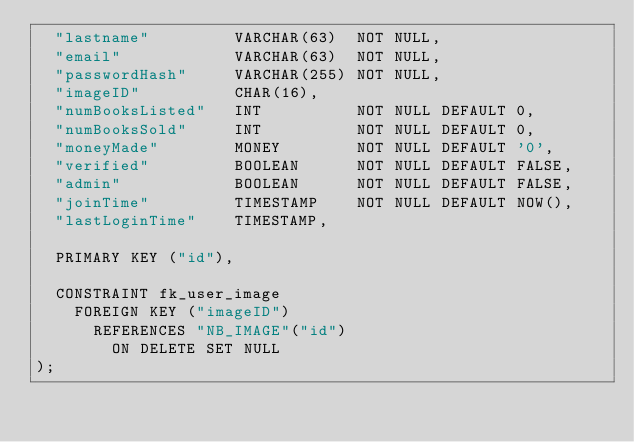<code> <loc_0><loc_0><loc_500><loc_500><_SQL_>  "lastname"         VARCHAR(63)  NOT NULL,
  "email"            VARCHAR(63)  NOT NULL,
  "passwordHash"     VARCHAR(255) NOT NULL,
  "imageID"          CHAR(16),
  "numBooksListed"   INT          NOT NULL DEFAULT 0,
  "numBooksSold"     INT          NOT NULL DEFAULT 0,
  "moneyMade"        MONEY        NOT NULL DEFAULT '0',
  "verified"         BOOLEAN      NOT NULL DEFAULT FALSE,
  "admin"            BOOLEAN      NOT NULL DEFAULT FALSE,
  "joinTime"         TIMESTAMP    NOT NULL DEFAULT NOW(),
  "lastLoginTime"    TIMESTAMP,

  PRIMARY KEY ("id"),

  CONSTRAINT fk_user_image
    FOREIGN KEY ("imageID")
      REFERENCES "NB_IMAGE"("id")
        ON DELETE SET NULL
);
</code> 